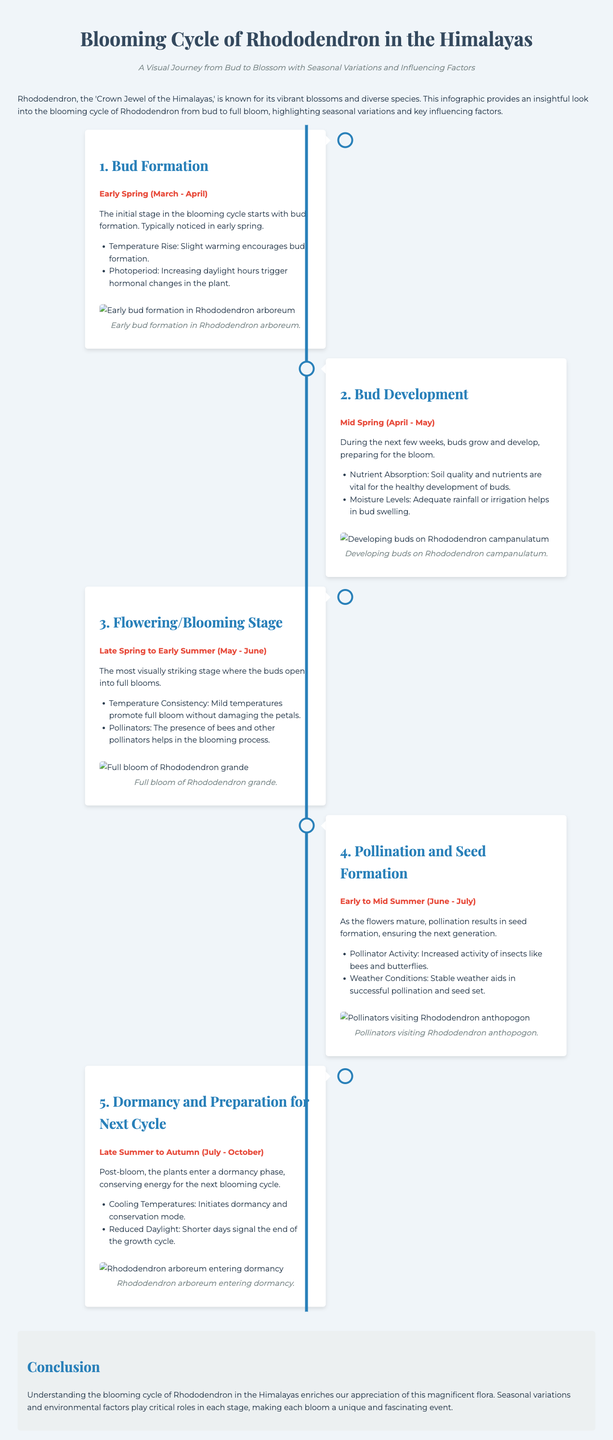What are the three key factors influencing bud formation? The document lists temperature rise, photoperiod, and nutrient absorption as influencing factors during bud formation.
Answer: Temperature Rise, Photoperiod, Nutrient Absorption What is the timeframe for the flowering stage? The flowering stage takes place from Late Spring to Early Summer, specifically noted as May to June.
Answer: May - June Which Rhododendron species is shown in the initial stage of bud formation? The infographic specifically mentions that early bud formation is depicted for Rhododendron arboreum.
Answer: Rhododendron arboreum What happens during the dormancy phase? The document states that the plants conserve energy and prepare for the next blooming cycle during dormancy.
Answer: Energy conservation Which external factor primarily aids in successful pollination? The infographic highlights stable weather conditions as a crucial factor for successful pollination.
Answer: Stable weather What visual element is included to depict bud development? A relevant image accompanying the bud development stage shows developing buds on Rhododendron campanulatum.
Answer: Developing buds on Rhododendron campanulatum How does the blooming cycle of Rhododendron enrich appreciation of flora? The conclusion emphasizes that understanding the blooming cycle enhances appreciation of this magnificent flora.
Answer: Enhances appreciation During which season do Rhododendrons enter dormancy? The document states that dormancy occurs from Late Summer to Autumn, specifically from July to October.
Answer: July - October 